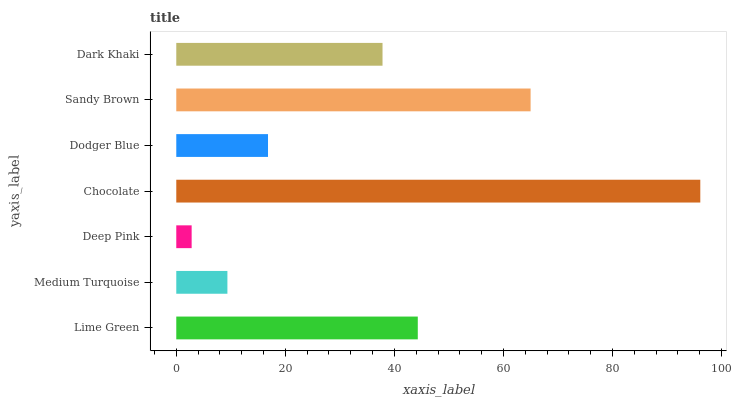Is Deep Pink the minimum?
Answer yes or no. Yes. Is Chocolate the maximum?
Answer yes or no. Yes. Is Medium Turquoise the minimum?
Answer yes or no. No. Is Medium Turquoise the maximum?
Answer yes or no. No. Is Lime Green greater than Medium Turquoise?
Answer yes or no. Yes. Is Medium Turquoise less than Lime Green?
Answer yes or no. Yes. Is Medium Turquoise greater than Lime Green?
Answer yes or no. No. Is Lime Green less than Medium Turquoise?
Answer yes or no. No. Is Dark Khaki the high median?
Answer yes or no. Yes. Is Dark Khaki the low median?
Answer yes or no. Yes. Is Medium Turquoise the high median?
Answer yes or no. No. Is Dodger Blue the low median?
Answer yes or no. No. 